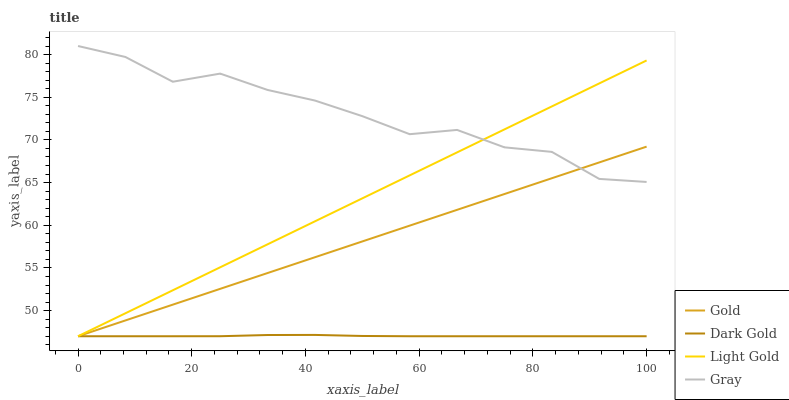Does Dark Gold have the minimum area under the curve?
Answer yes or no. Yes. Does Gray have the maximum area under the curve?
Answer yes or no. Yes. Does Light Gold have the minimum area under the curve?
Answer yes or no. No. Does Light Gold have the maximum area under the curve?
Answer yes or no. No. Is Gold the smoothest?
Answer yes or no. Yes. Is Gray the roughest?
Answer yes or no. Yes. Is Light Gold the smoothest?
Answer yes or no. No. Is Light Gold the roughest?
Answer yes or no. No. Does Gray have the highest value?
Answer yes or no. Yes. Does Light Gold have the highest value?
Answer yes or no. No. Is Dark Gold less than Gray?
Answer yes or no. Yes. Is Gray greater than Dark Gold?
Answer yes or no. Yes. Does Gray intersect Gold?
Answer yes or no. Yes. Is Gray less than Gold?
Answer yes or no. No. Is Gray greater than Gold?
Answer yes or no. No. Does Dark Gold intersect Gray?
Answer yes or no. No. 